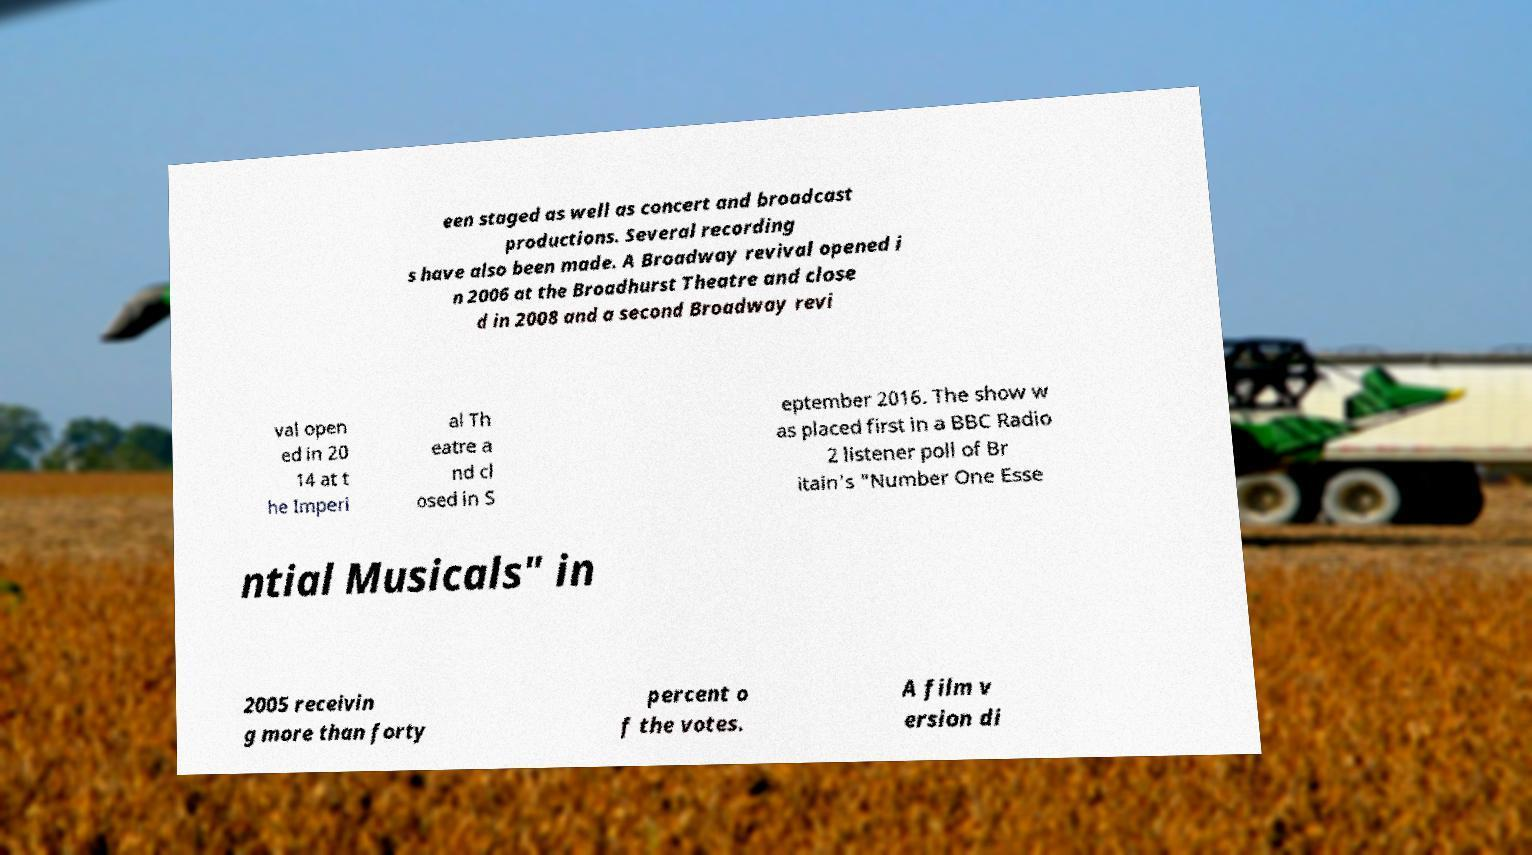What messages or text are displayed in this image? I need them in a readable, typed format. een staged as well as concert and broadcast productions. Several recording s have also been made. A Broadway revival opened i n 2006 at the Broadhurst Theatre and close d in 2008 and a second Broadway revi val open ed in 20 14 at t he Imperi al Th eatre a nd cl osed in S eptember 2016. The show w as placed first in a BBC Radio 2 listener poll of Br itain's "Number One Esse ntial Musicals" in 2005 receivin g more than forty percent o f the votes. A film v ersion di 